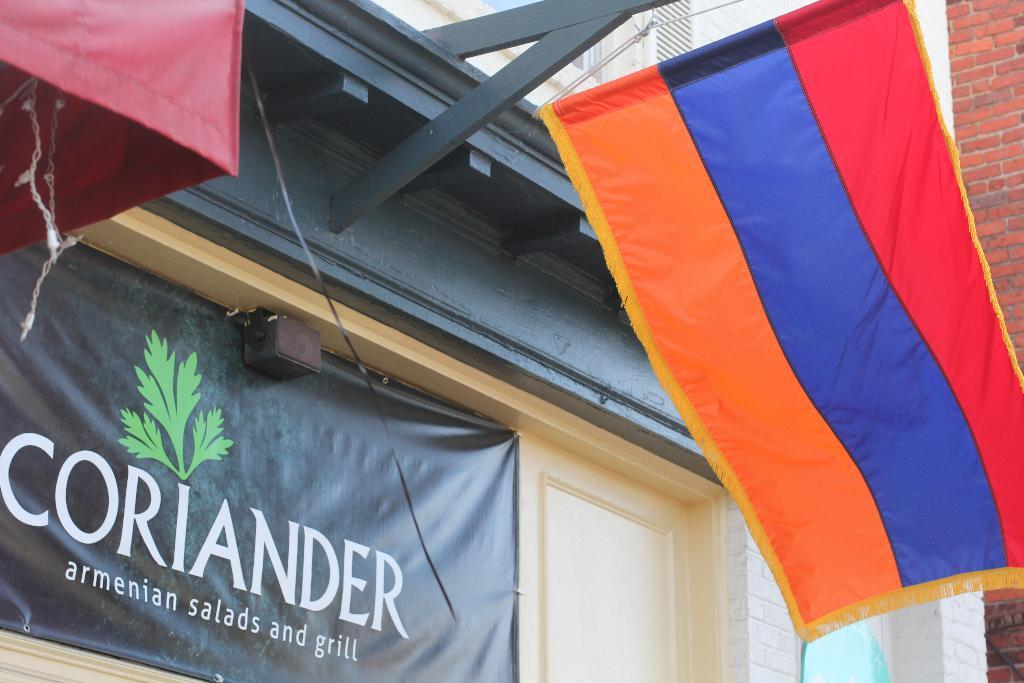What type of structure is present in the image? There is a building in the image. What can be seen hanging or displayed in the image? Colorful clothes and a banner are visible in the image. What type of wall is present in the image? There is a brick wall in the image. What part of the building can be used for entering or exiting? There is a door panel at the bottom portion of the image. How many pizzas are being served on the bucket in the image? There is no bucket or pizzas present in the image. What type of blade is being used to cut the clothes in the image? There is no blade or cutting of clothes depicted in the image. 